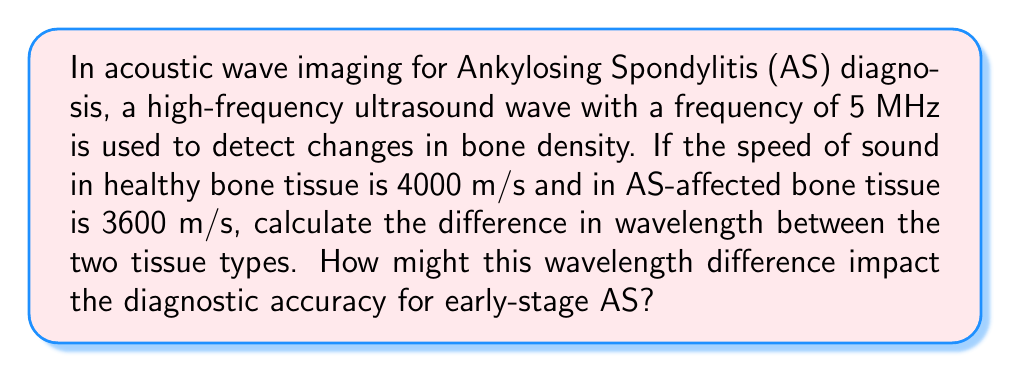Give your solution to this math problem. To solve this problem, we'll follow these steps:

1) First, recall the wave equation: $v = f \lambda$, where $v$ is the wave speed, $f$ is the frequency, and $\lambda$ is the wavelength.

2) For healthy bone tissue:
   $4000 = 5 \times 10^6 \lambda_h$
   $\lambda_h = \frac{4000}{5 \times 10^6} = 8 \times 10^{-4}$ m = 0.8 mm

3) For AS-affected bone tissue:
   $3600 = 5 \times 10^6 \lambda_a$
   $\lambda_a = \frac{3600}{5 \times 10^6} = 7.2 \times 10^{-4}$ m = 0.72 mm

4) The difference in wavelength:
   $\Delta \lambda = \lambda_h - \lambda_a = 0.8 - 0.72 = 0.08$ mm

5) Impact on diagnostic accuracy:
   The 0.08 mm difference in wavelength could significantly impact early-stage AS diagnosis. This difference, while small, can be detected by high-resolution ultrasound devices. In early-stage AS, bone density changes are subtle, and this wavelength difference provides a quantifiable metric for detecting these early changes. However, the small difference also means that the imaging technique must be highly precise to differentiate between healthy and affected tissue, especially in early stages of the disease where changes are minimal.
Answer: 0.08 mm; Enhances early detection but requires high precision. 